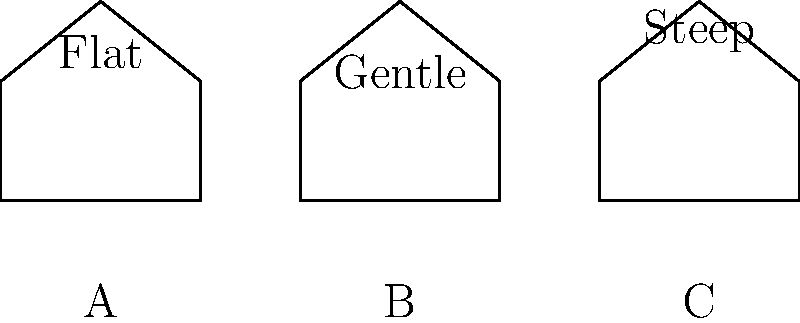In this roofing riddle, which of these abodes might leave you high and dry during a downpour, while the others risk turning your attic into an aquarium? Consider the angle of the dangle (of water, that is) and pick the pitched perfectionist. Let's break down this rain-shedding conundrum step by step:

1. Roof pitch and water flow:
   - Steeper roofs allow water to flow off more quickly due to gravity's increased effect on the angled surface.
   - Flatter roofs tend to accumulate water, potentially leading to leaks or structural damage.

2. Analyzing the options:
   A. Flat roof: The least efficient at shedding water. It may pool water, leading to potential leaks and damage.
   B. Gentle slope: Better than flat, but still not optimal for rapid water drainage.
   C. Steep roof: The most efficient at quickly shedding rainwater.

3. Water velocity on inclined planes:
   The velocity of water on an inclined plane is given by the equation:
   $$ v = \sqrt{2gh\sin\theta} $$
   Where:
   $v$ = velocity
   $g$ = acceleration due to gravity
   $h$ = height of the water layer
   $\theta$ = angle of inclination

4. Comparing efficiencies:
   - As $\theta$ increases, $\sin\theta$ increases, resulting in higher water velocity.
   - The steep roof (C) has the largest $\theta$, thus the highest water velocity and most efficient drainage.

5. Additional benefits of steep roofs:
   - Less likely to accumulate debris (leaves, snow, etc.)
   - Reduced risk of ice dams in cold climates
   - Potentially longer lifespan due to less water exposure

Therefore, the steep roof (C) is the most efficient at shedding rainwater, keeping your attic dry and your puns from getting watered down.
Answer: C (Steep roof) 